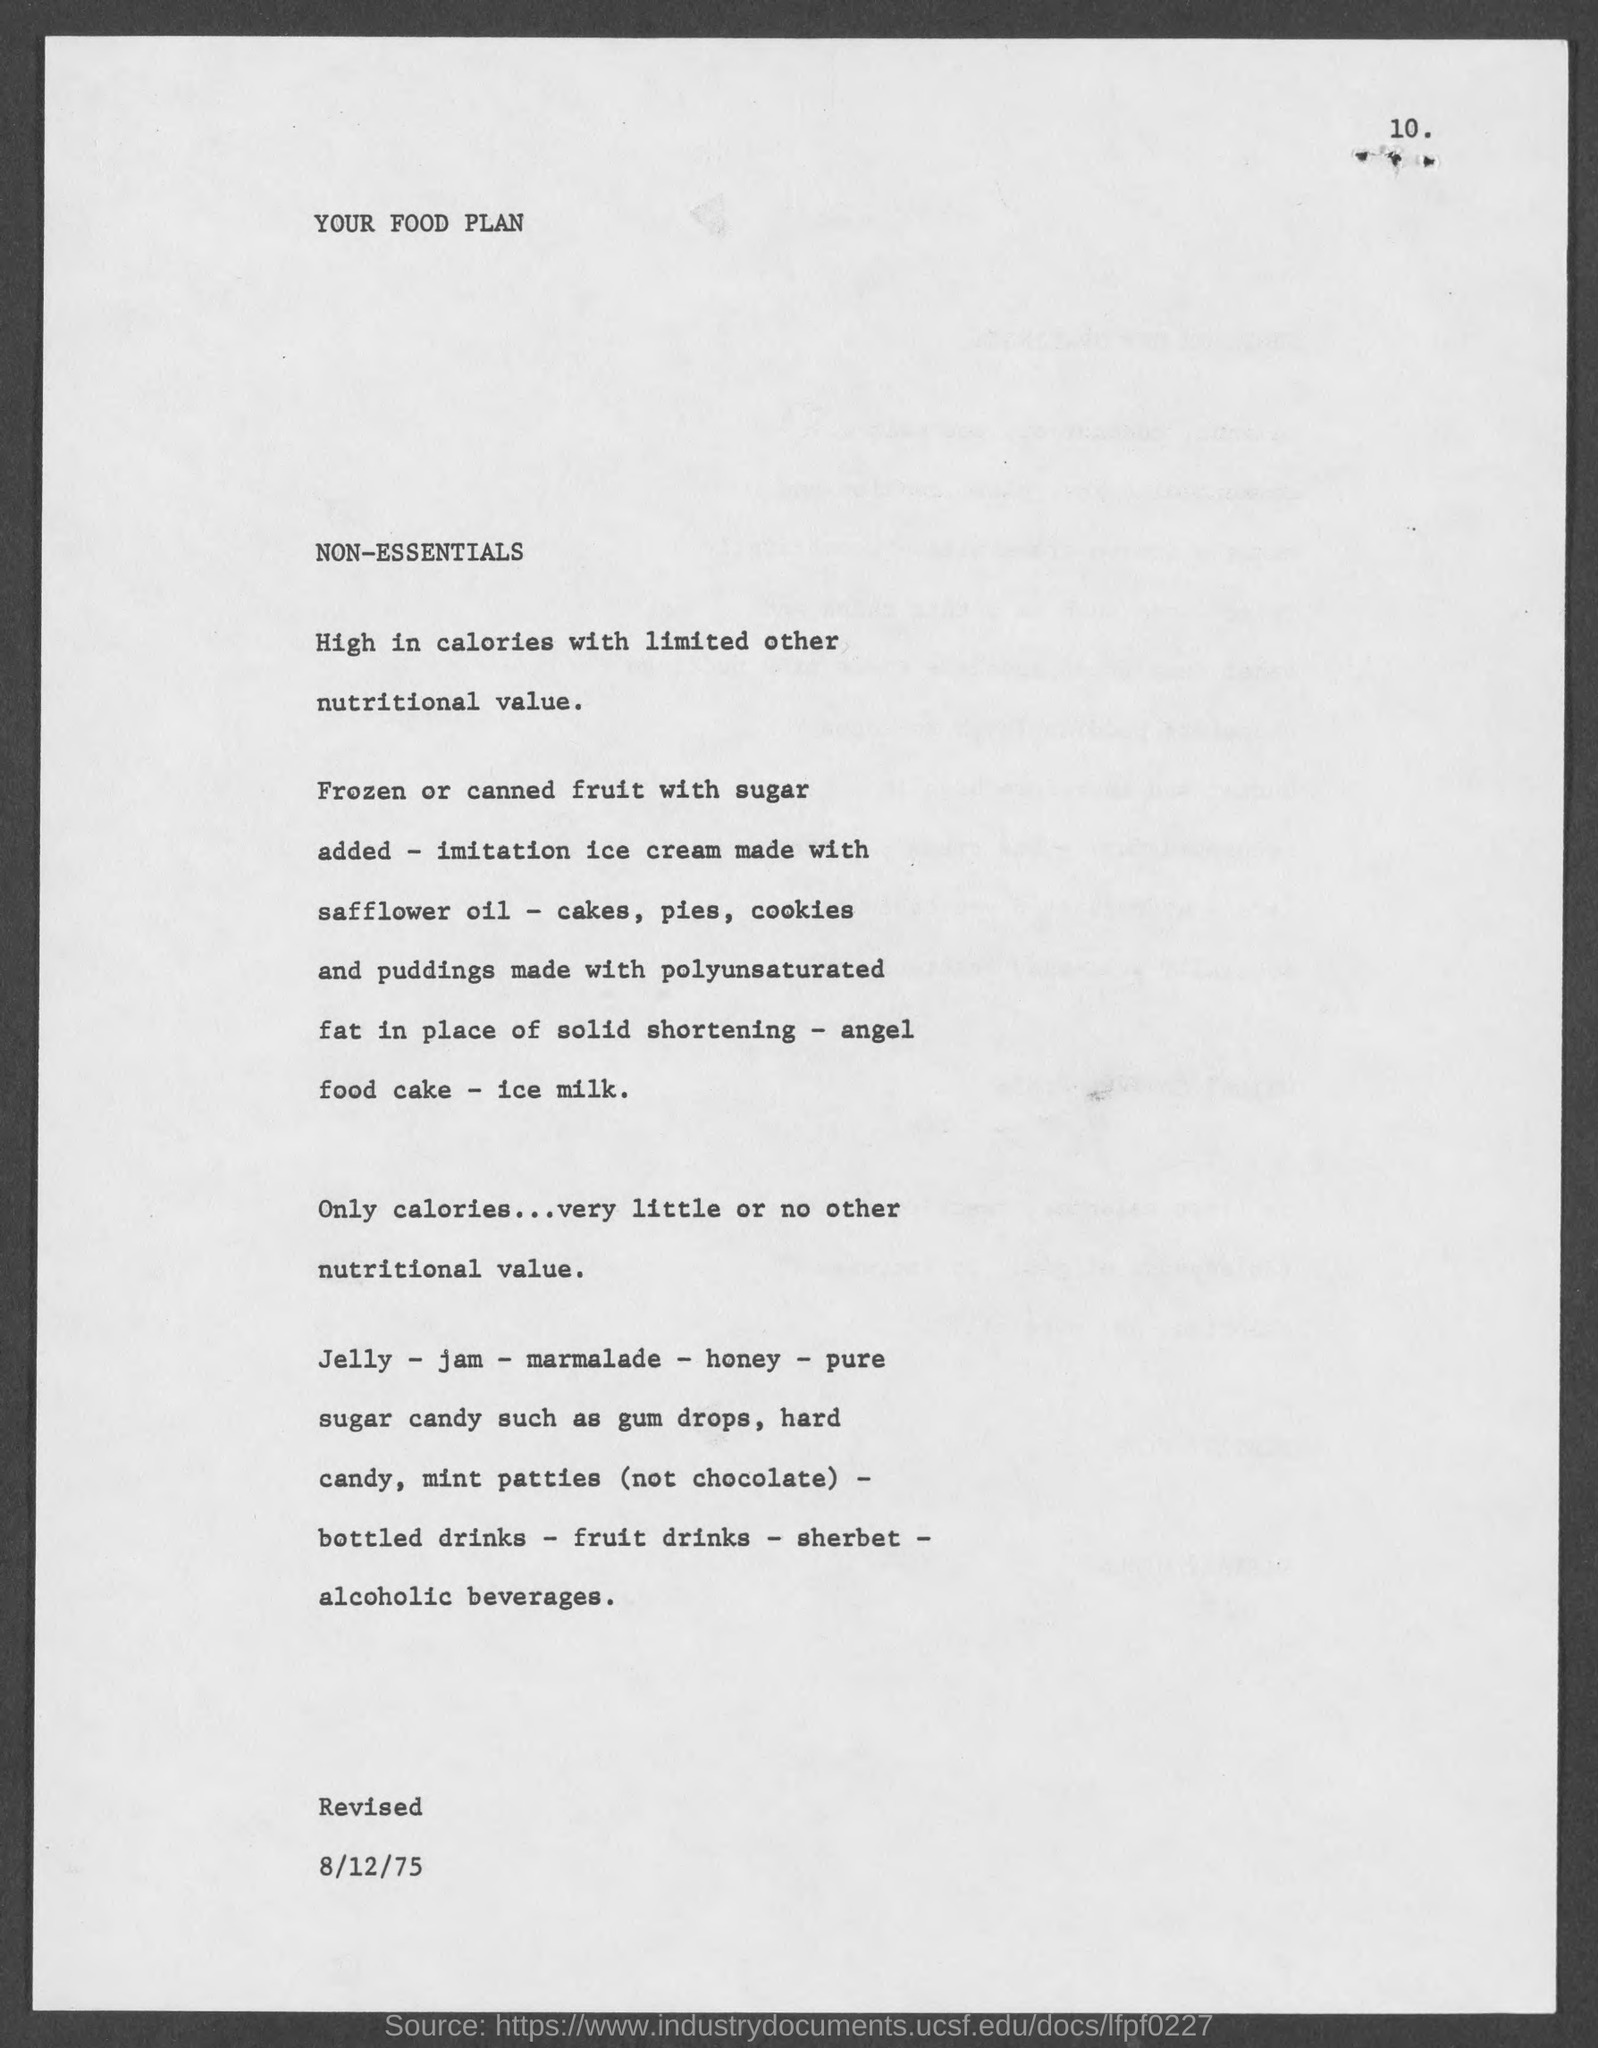Give some essential details in this illustration. The title of the document is "Your Food Plan. 